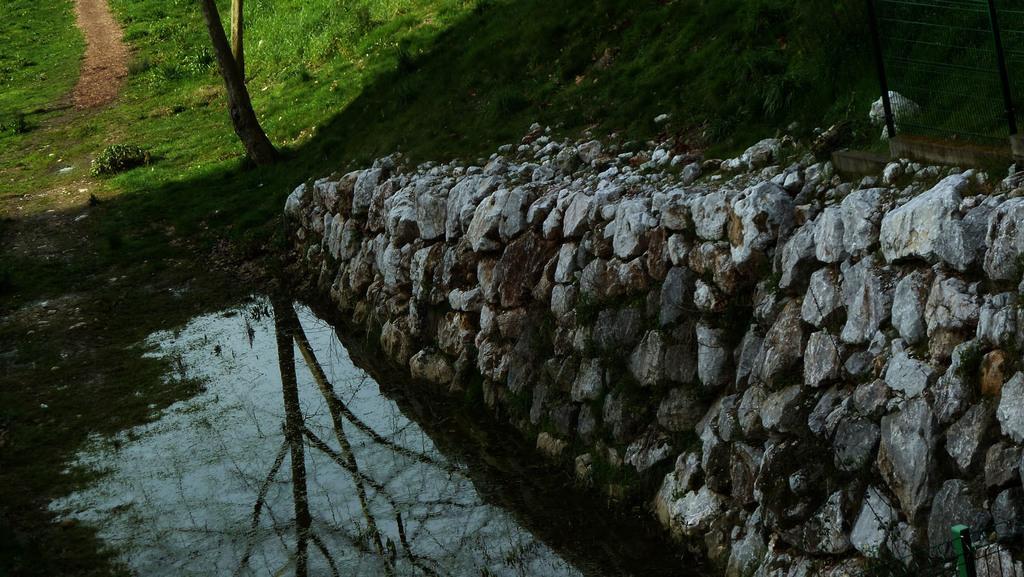Describe this image in one or two sentences. In this picture I can see rocks, grass, there is a reflection of trees and the sky on the water. 